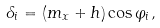Convert formula to latex. <formula><loc_0><loc_0><loc_500><loc_500>\delta _ { i } = ( m _ { x } + h ) \cos \varphi _ { i } ,</formula> 